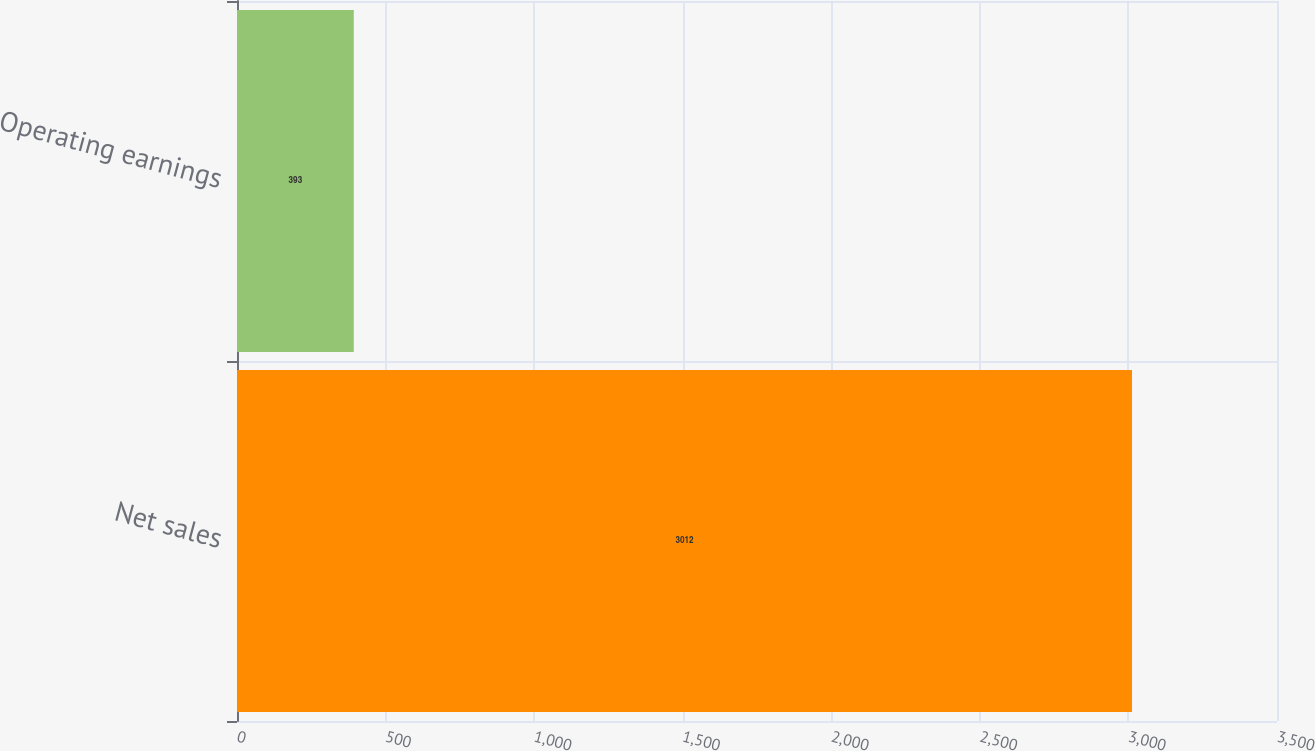Convert chart. <chart><loc_0><loc_0><loc_500><loc_500><bar_chart><fcel>Net sales<fcel>Operating earnings<nl><fcel>3012<fcel>393<nl></chart> 